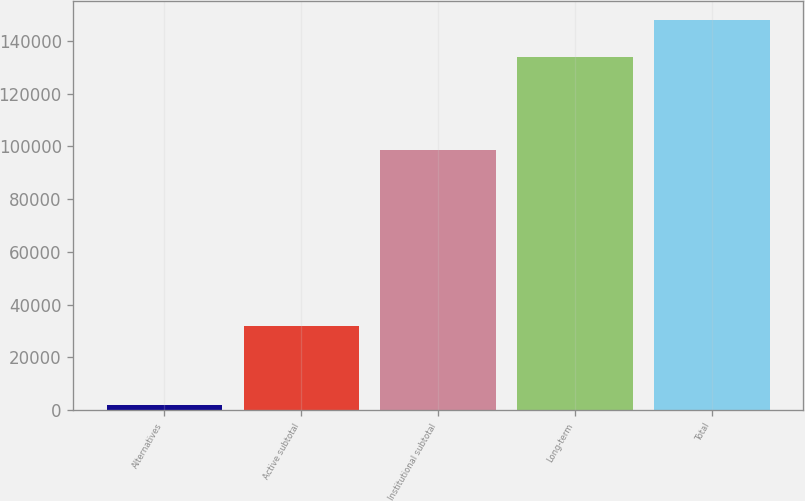Convert chart to OTSL. <chart><loc_0><loc_0><loc_500><loc_500><bar_chart><fcel>Alternatives<fcel>Active subtotal<fcel>Institutional subtotal<fcel>Long-term<fcel>Total<nl><fcel>2032<fcel>31993<fcel>98698<fcel>133874<fcel>147763<nl></chart> 